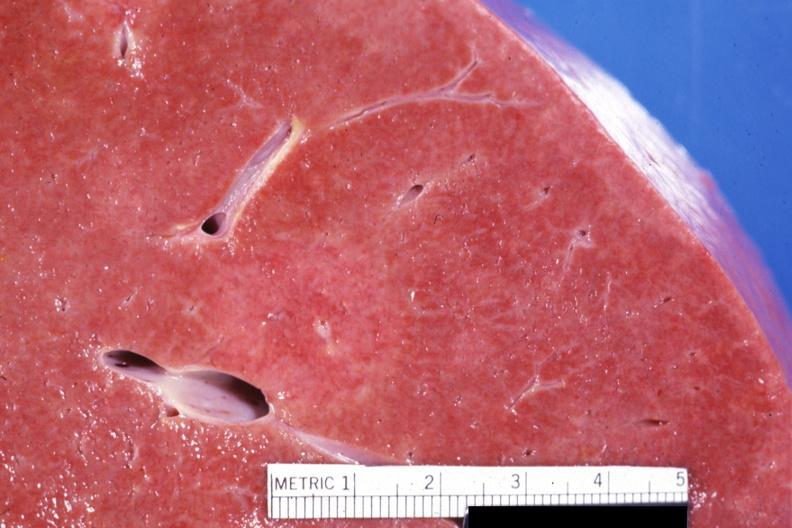what is present?
Answer the question using a single word or phrase. Liver 